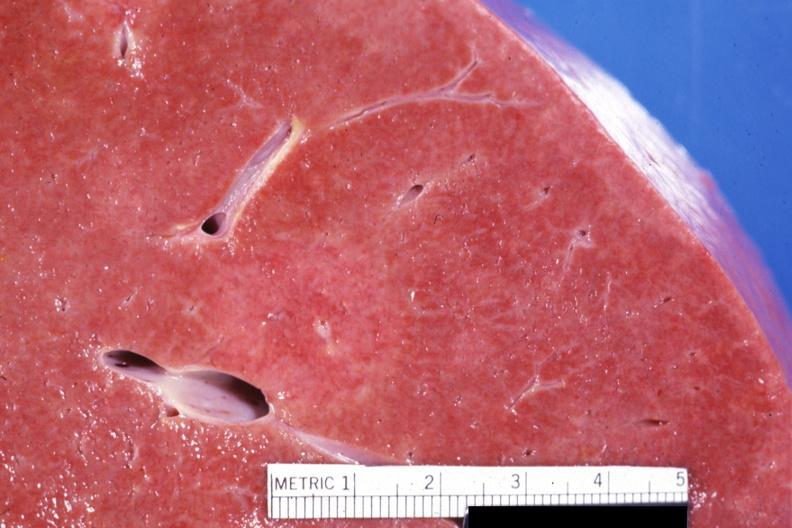what is present?
Answer the question using a single word or phrase. Liver 